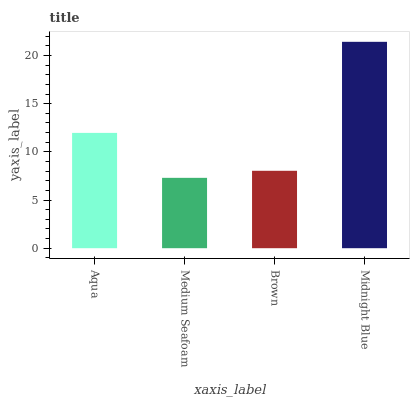Is Brown the minimum?
Answer yes or no. No. Is Brown the maximum?
Answer yes or no. No. Is Brown greater than Medium Seafoam?
Answer yes or no. Yes. Is Medium Seafoam less than Brown?
Answer yes or no. Yes. Is Medium Seafoam greater than Brown?
Answer yes or no. No. Is Brown less than Medium Seafoam?
Answer yes or no. No. Is Aqua the high median?
Answer yes or no. Yes. Is Brown the low median?
Answer yes or no. Yes. Is Brown the high median?
Answer yes or no. No. Is Midnight Blue the low median?
Answer yes or no. No. 